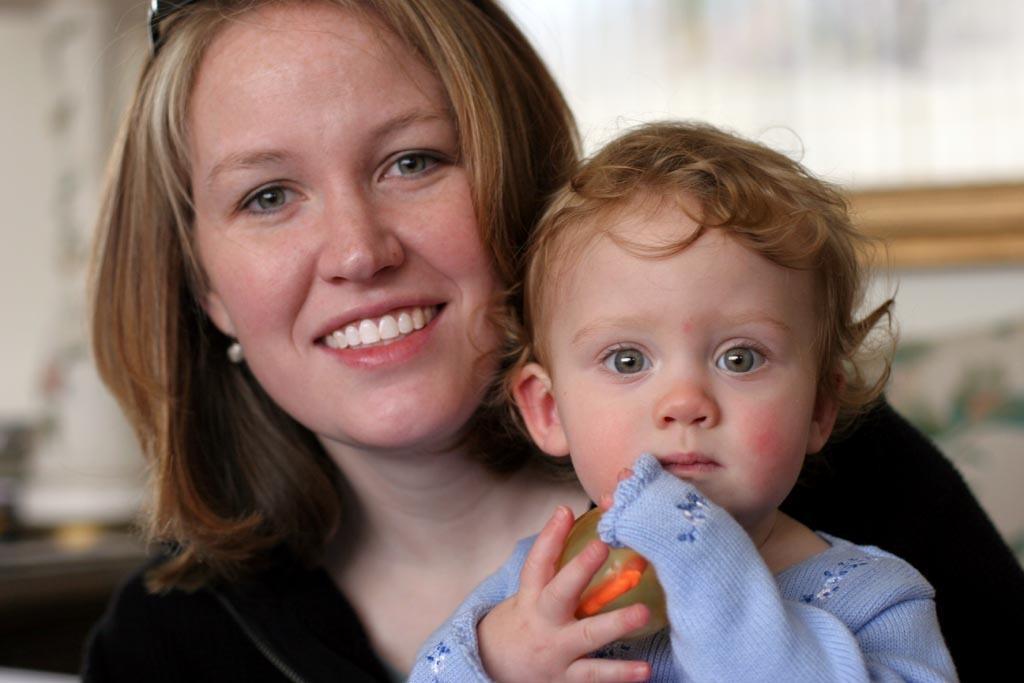How would you summarize this image in a sentence or two? In this picture we can see a woman, she is smiling, and she is holding a baby. 